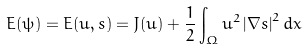Convert formula to latex. <formula><loc_0><loc_0><loc_500><loc_500>E ( \psi ) = E ( u , s ) = J ( u ) + \frac { 1 } { 2 } \int \nolimits _ { \Omega } u ^ { 2 } \left | \nabla s \right | ^ { 2 } d x</formula> 